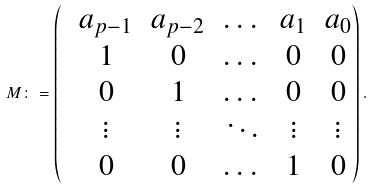Convert formula to latex. <formula><loc_0><loc_0><loc_500><loc_500>M \colon = \left ( \begin{matrix} & a _ { p - 1 } & a _ { p - 2 } & \dots & a _ { 1 } & a _ { 0 } \\ & 1 & 0 & \dots & 0 & 0 \\ & 0 & 1 & \dots & 0 & 0 \\ & \vdots & \vdots & \ddots & \vdots & \vdots \\ & 0 & 0 & \dots & 1 & 0 \\ \end{matrix} \right ) .</formula> 